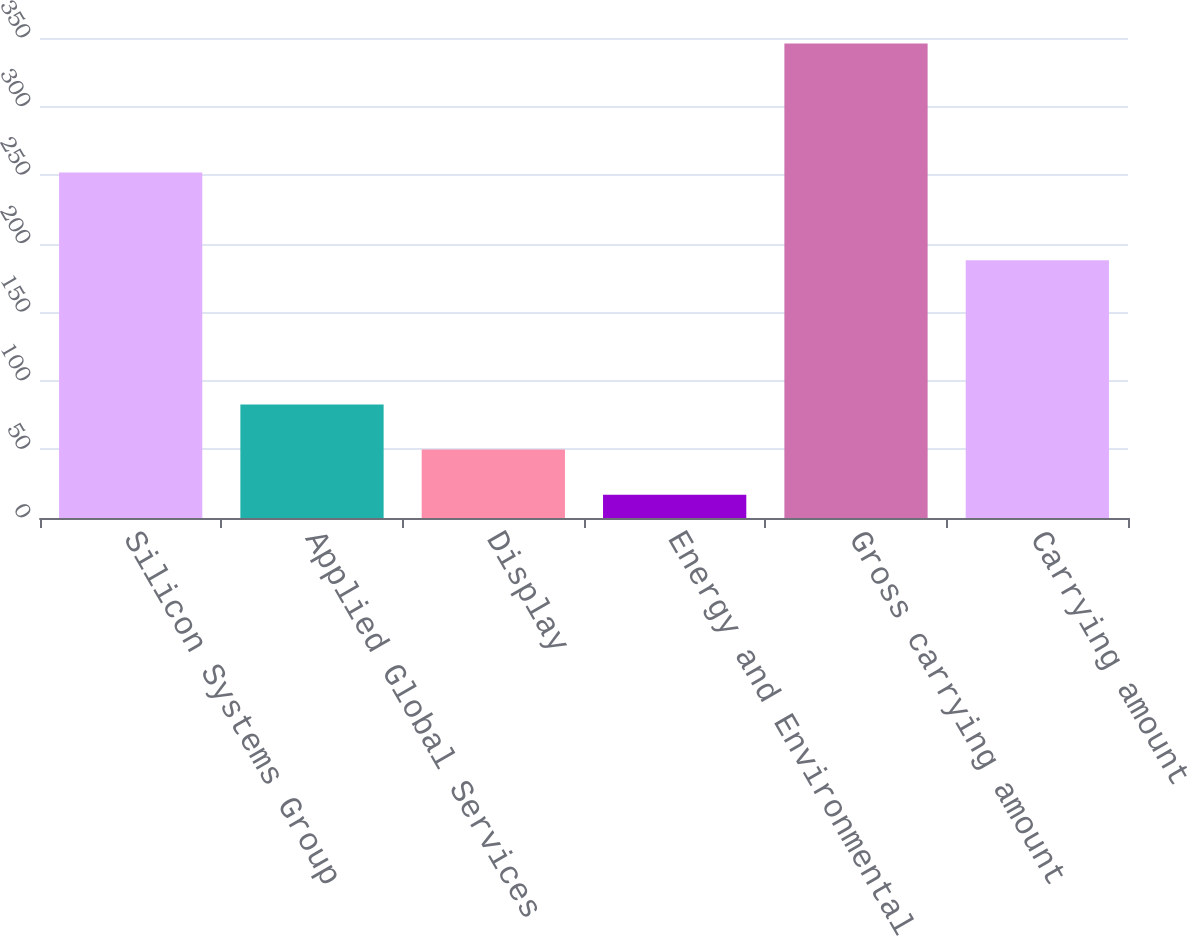<chart> <loc_0><loc_0><loc_500><loc_500><bar_chart><fcel>Silicon Systems Group<fcel>Applied Global Services<fcel>Display<fcel>Energy and Environmental<fcel>Gross carrying amount<fcel>Carrying amount<nl><fcel>252<fcel>82.8<fcel>49.9<fcel>17<fcel>346<fcel>188<nl></chart> 